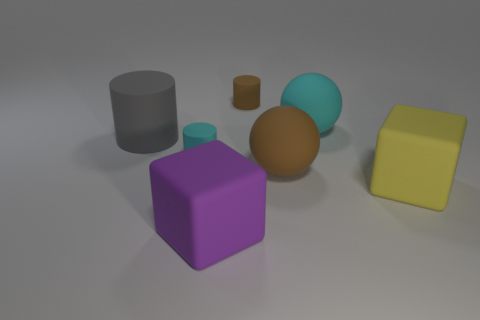Is the number of small cyan matte cylinders behind the large yellow object greater than the number of matte cubes behind the cyan ball?
Offer a terse response. Yes. What is the color of the tiny matte thing on the right side of the rubber block that is in front of the yellow thing?
Offer a very short reply. Brown. Do the yellow block and the small cyan cylinder have the same material?
Provide a short and direct response. Yes. Is there another big object that has the same shape as the yellow object?
Offer a very short reply. Yes. There is a cyan matte thing on the right side of the big brown sphere; is its size the same as the cyan object that is on the left side of the large purple matte block?
Provide a short and direct response. No. There is another cube that is the same material as the purple block; what size is it?
Ensure brevity in your answer.  Large. What number of big things are both to the left of the large purple thing and in front of the gray matte object?
Offer a terse response. 0. What number of things are either large red shiny cylinders or big rubber cubes that are left of the brown matte cylinder?
Your response must be concise. 1. What color is the large rubber thing in front of the big yellow rubber object?
Your response must be concise. Purple. How many things are either cyan objects in front of the gray matte cylinder or small cyan rubber things?
Keep it short and to the point. 1. 